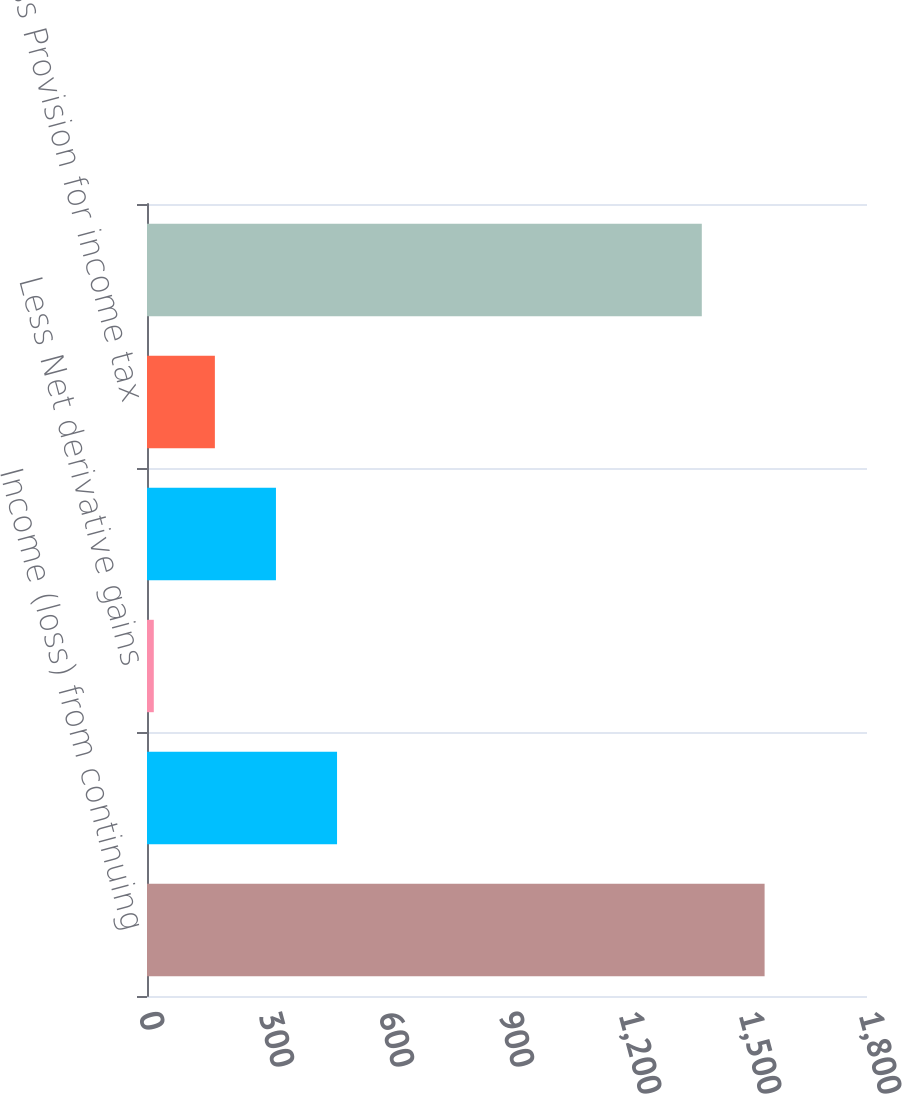<chart> <loc_0><loc_0><loc_500><loc_500><bar_chart><fcel>Income (loss) from continuing<fcel>Less Net investment gains<fcel>Less Net derivative gains<fcel>Less Other adjustments to<fcel>Less Provision for income tax<fcel>Operating earnings<nl><fcel>1544<fcel>475.1<fcel>17<fcel>322.4<fcel>169.7<fcel>1387<nl></chart> 